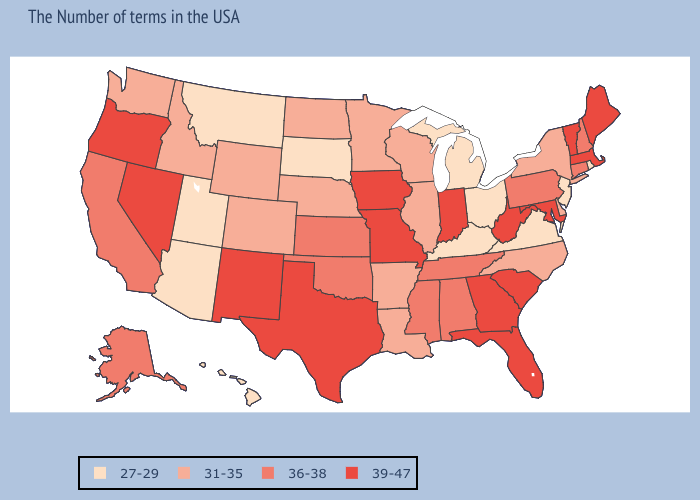Name the states that have a value in the range 27-29?
Concise answer only. Rhode Island, New Jersey, Virginia, Ohio, Michigan, Kentucky, South Dakota, Utah, Montana, Arizona, Hawaii. Name the states that have a value in the range 31-35?
Keep it brief. New York, Delaware, North Carolina, Wisconsin, Illinois, Louisiana, Arkansas, Minnesota, Nebraska, North Dakota, Wyoming, Colorado, Idaho, Washington. What is the value of Indiana?
Be succinct. 39-47. Does Ohio have a lower value than Georgia?
Answer briefly. Yes. Does Arkansas have a lower value than Iowa?
Write a very short answer. Yes. Which states have the lowest value in the Northeast?
Write a very short answer. Rhode Island, New Jersey. What is the highest value in states that border Wyoming?
Keep it brief. 31-35. Name the states that have a value in the range 36-38?
Give a very brief answer. New Hampshire, Connecticut, Pennsylvania, Alabama, Tennessee, Mississippi, Kansas, Oklahoma, California, Alaska. Does South Dakota have the highest value in the MidWest?
Short answer required. No. What is the value of South Carolina?
Concise answer only. 39-47. What is the value of Oregon?
Short answer required. 39-47. Among the states that border Montana , which have the lowest value?
Concise answer only. South Dakota. Which states have the highest value in the USA?
Write a very short answer. Maine, Massachusetts, Vermont, Maryland, South Carolina, West Virginia, Florida, Georgia, Indiana, Missouri, Iowa, Texas, New Mexico, Nevada, Oregon. Does Rhode Island have the lowest value in the Northeast?
Answer briefly. Yes. Name the states that have a value in the range 31-35?
Short answer required. New York, Delaware, North Carolina, Wisconsin, Illinois, Louisiana, Arkansas, Minnesota, Nebraska, North Dakota, Wyoming, Colorado, Idaho, Washington. 